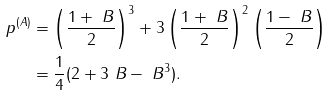Convert formula to latex. <formula><loc_0><loc_0><loc_500><loc_500>p ^ { ( A ) } & = \left ( \frac { 1 + \ B } { 2 } \right ) ^ { 3 } + 3 \left ( \frac { 1 + \ B } { 2 } \right ) ^ { 2 } \left ( \frac { 1 - \ B } { 2 } \right ) \\ & = \frac { 1 } { 4 } ( 2 + 3 \ B - \ B ^ { 3 } ) .</formula> 